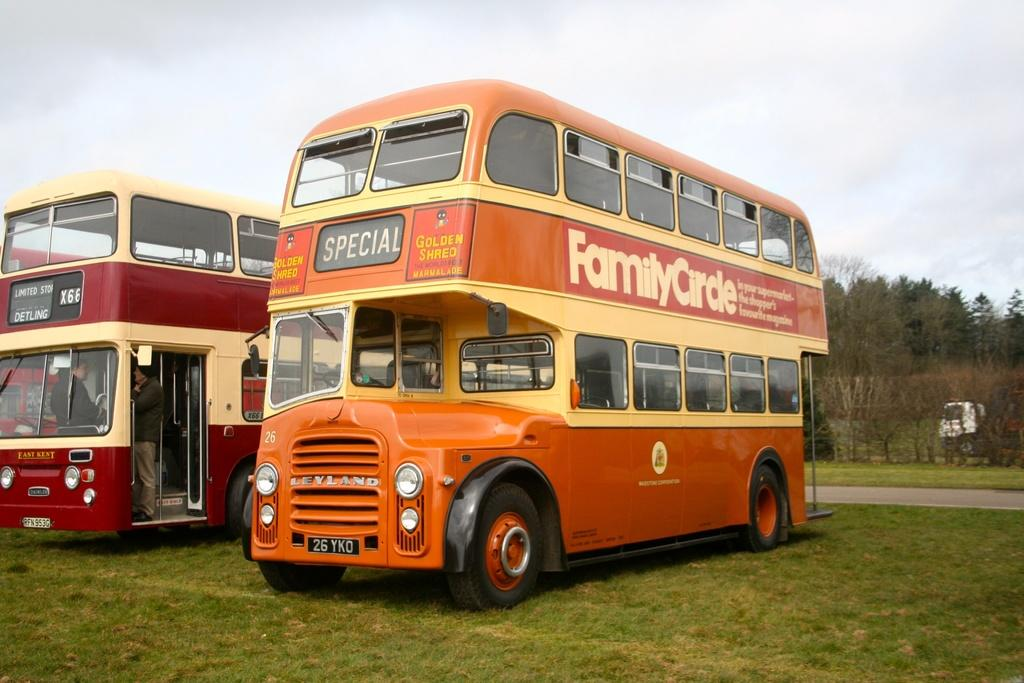<image>
Share a concise interpretation of the image provided. A red double decker bus next to an orange bus with license plate 26YKO. 